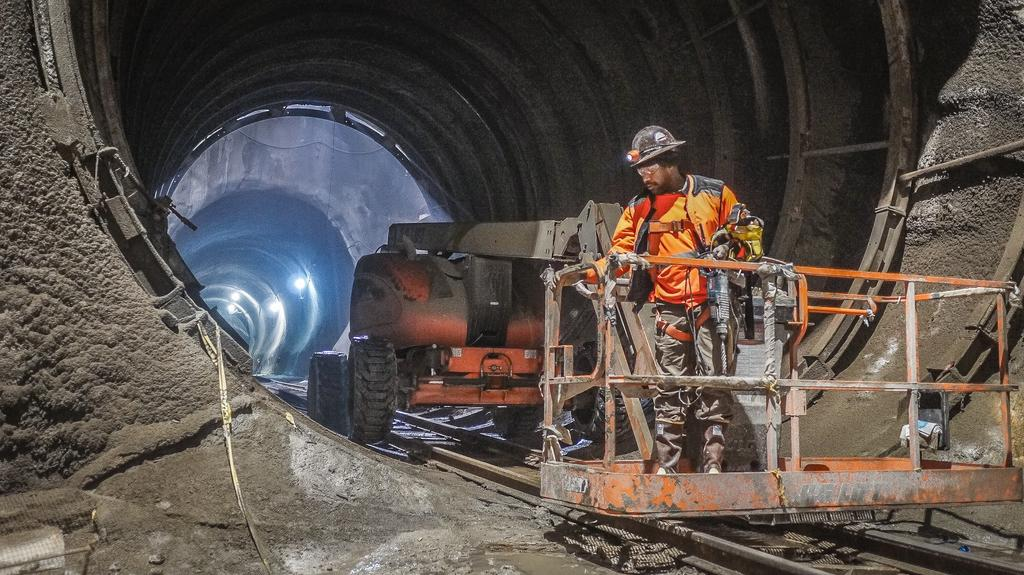What is the main subject of the image? There is a man standing in the image. What else can be seen in the image besides the man? There is a vehicle, a tunnel, lights, metal objects on the wall of the tunnel, and a track in the image. What type of oven can be seen in the image? There is no oven present in the image. What country is the man from in the image? The image does not provide any information about the man's country of origin. 